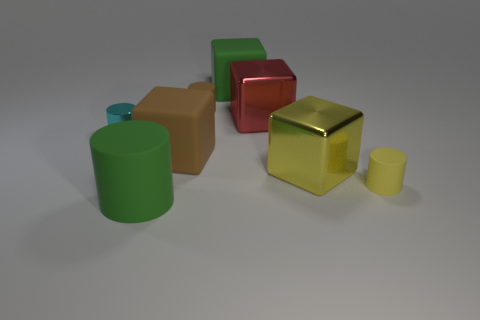There is a rubber thing that is to the right of the large green rubber object that is behind the green rubber thing that is in front of the big green matte block; what size is it?
Provide a succinct answer. Small. How many red things are in front of the brown cylinder?
Make the answer very short. 1. What material is the small cylinder that is to the left of the green matte object on the left side of the big brown rubber cube made of?
Keep it short and to the point. Metal. Do the cyan thing and the red metallic object have the same size?
Your answer should be compact. No. What number of things are either metal blocks left of the yellow metallic thing or tiny rubber cylinders that are behind the yellow metallic block?
Provide a short and direct response. 2. Is the number of big cubes that are behind the small brown matte cylinder greater than the number of purple cylinders?
Provide a short and direct response. Yes. How many other things are there of the same shape as the yellow shiny object?
Ensure brevity in your answer.  3. What is the cylinder that is both in front of the large yellow metal thing and behind the big green cylinder made of?
Offer a terse response. Rubber. How many things are small cyan cylinders or small brown things?
Your response must be concise. 2. Is the number of tiny yellow spheres greater than the number of small brown objects?
Make the answer very short. No. 